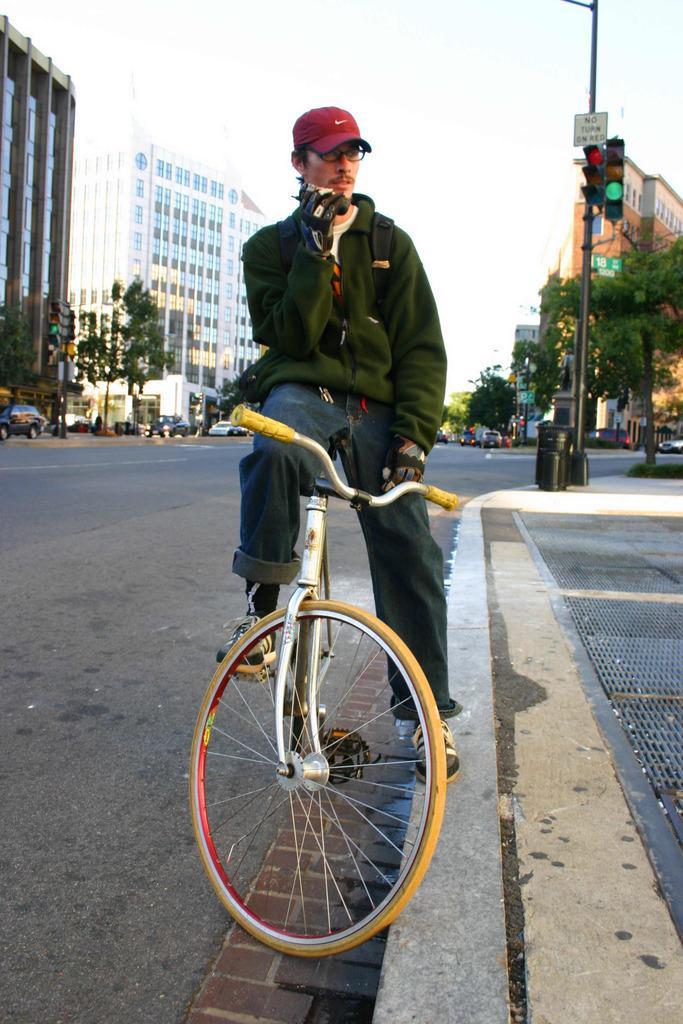Describe this image in one or two sentences. This person sitting on the bicycle wear cap and glasses. A far we can see buildings,trees and vehicles on the road. We can see pole with traffic signal. 